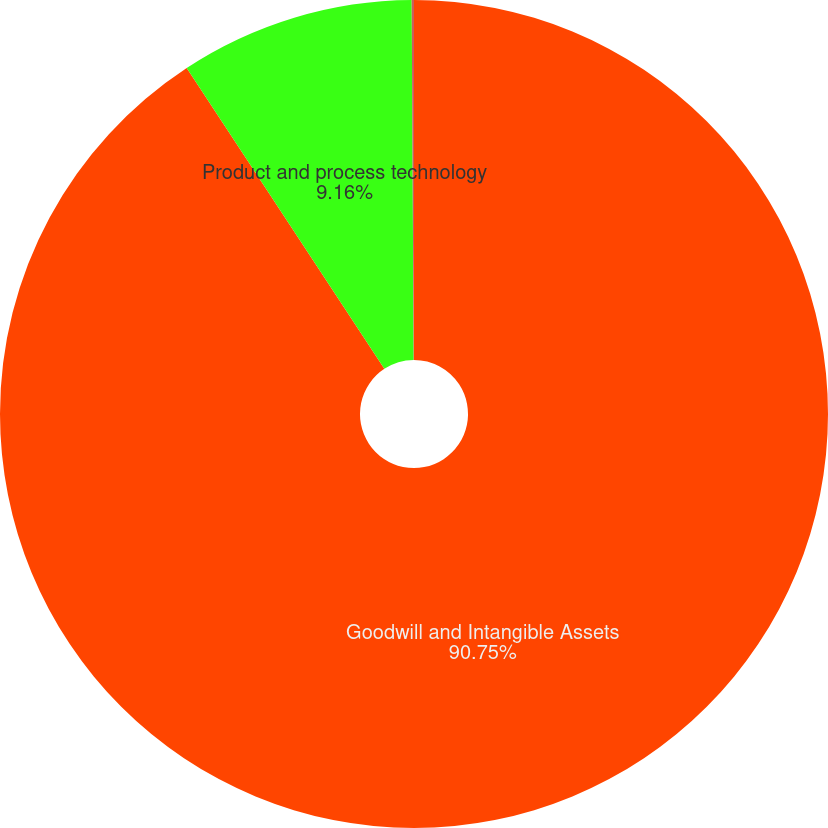Convert chart to OTSL. <chart><loc_0><loc_0><loc_500><loc_500><pie_chart><fcel>Goodwill and Intangible Assets<fcel>Product and process technology<fcel>Other<nl><fcel>90.75%<fcel>9.16%<fcel>0.09%<nl></chart> 